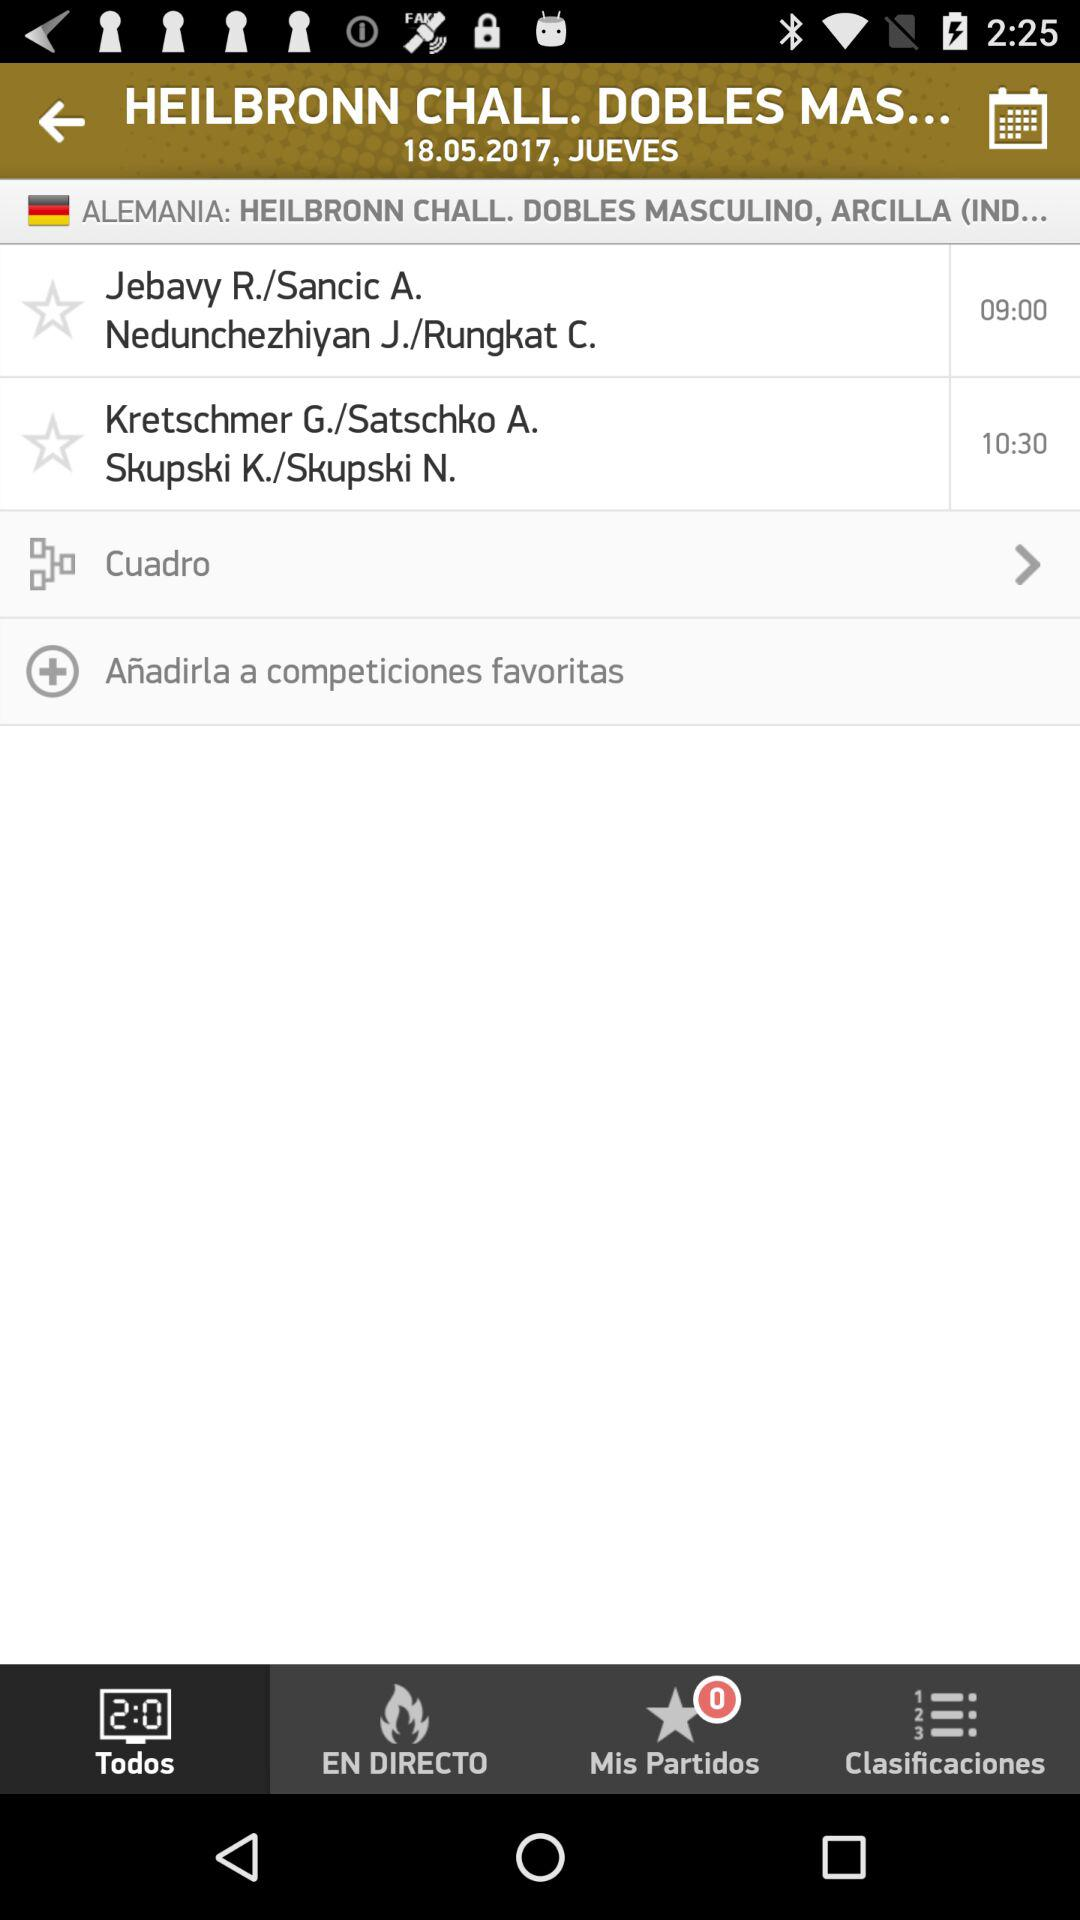How many matches are scheduled for 10:30?
Answer the question using a single word or phrase. 1 